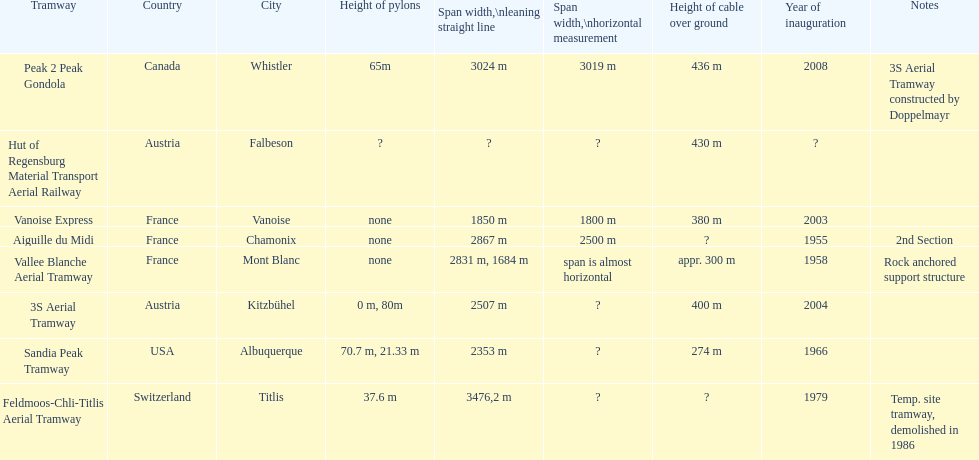At least how many aerial tramways were inaugurated after 1970? 4. 